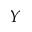Convert formula to latex. <formula><loc_0><loc_0><loc_500><loc_500>Y</formula> 